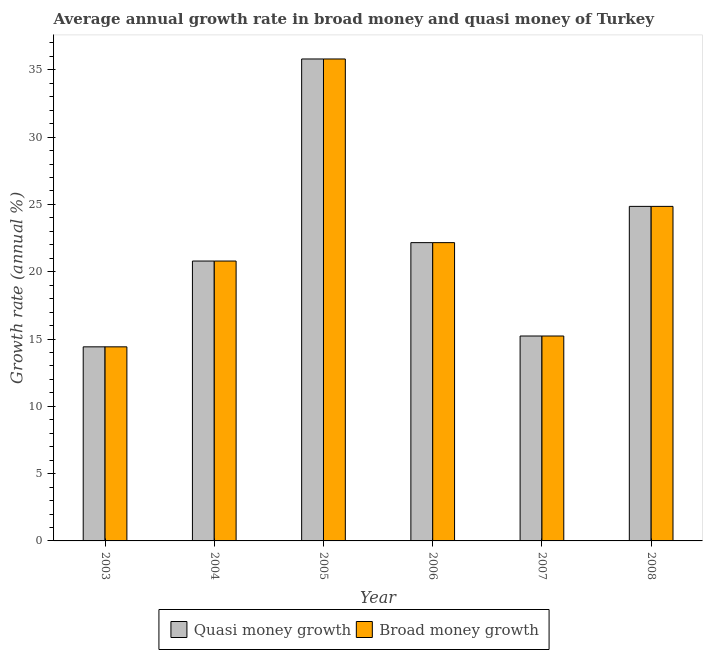How many different coloured bars are there?
Provide a short and direct response. 2. How many groups of bars are there?
Provide a succinct answer. 6. Are the number of bars per tick equal to the number of legend labels?
Your answer should be compact. Yes. How many bars are there on the 5th tick from the right?
Provide a short and direct response. 2. In how many cases, is the number of bars for a given year not equal to the number of legend labels?
Your response must be concise. 0. What is the annual growth rate in quasi money in 2005?
Offer a terse response. 35.81. Across all years, what is the maximum annual growth rate in broad money?
Make the answer very short. 35.81. Across all years, what is the minimum annual growth rate in broad money?
Provide a short and direct response. 14.42. In which year was the annual growth rate in quasi money maximum?
Give a very brief answer. 2005. What is the total annual growth rate in broad money in the graph?
Provide a succinct answer. 133.27. What is the difference between the annual growth rate in quasi money in 2005 and that in 2007?
Provide a short and direct response. 20.58. What is the difference between the annual growth rate in broad money in 2005 and the annual growth rate in quasi money in 2004?
Offer a terse response. 15.01. What is the average annual growth rate in quasi money per year?
Offer a very short reply. 22.21. In the year 2008, what is the difference between the annual growth rate in broad money and annual growth rate in quasi money?
Keep it short and to the point. 0. In how many years, is the annual growth rate in quasi money greater than 33 %?
Your answer should be compact. 1. What is the ratio of the annual growth rate in quasi money in 2003 to that in 2006?
Offer a terse response. 0.65. Is the annual growth rate in broad money in 2003 less than that in 2004?
Offer a very short reply. Yes. What is the difference between the highest and the second highest annual growth rate in quasi money?
Provide a succinct answer. 10.95. What is the difference between the highest and the lowest annual growth rate in broad money?
Ensure brevity in your answer.  21.39. In how many years, is the annual growth rate in quasi money greater than the average annual growth rate in quasi money taken over all years?
Provide a short and direct response. 2. Is the sum of the annual growth rate in quasi money in 2007 and 2008 greater than the maximum annual growth rate in broad money across all years?
Give a very brief answer. Yes. What does the 2nd bar from the left in 2003 represents?
Your answer should be compact. Broad money growth. What does the 2nd bar from the right in 2008 represents?
Provide a succinct answer. Quasi money growth. How many bars are there?
Keep it short and to the point. 12. What is the difference between two consecutive major ticks on the Y-axis?
Ensure brevity in your answer.  5. Are the values on the major ticks of Y-axis written in scientific E-notation?
Your response must be concise. No. Does the graph contain any zero values?
Provide a short and direct response. No. How are the legend labels stacked?
Offer a very short reply. Horizontal. What is the title of the graph?
Your answer should be very brief. Average annual growth rate in broad money and quasi money of Turkey. What is the label or title of the X-axis?
Your answer should be compact. Year. What is the label or title of the Y-axis?
Your response must be concise. Growth rate (annual %). What is the Growth rate (annual %) in Quasi money growth in 2003?
Your answer should be very brief. 14.42. What is the Growth rate (annual %) in Broad money growth in 2003?
Your response must be concise. 14.42. What is the Growth rate (annual %) of Quasi money growth in 2004?
Provide a short and direct response. 20.8. What is the Growth rate (annual %) of Broad money growth in 2004?
Make the answer very short. 20.8. What is the Growth rate (annual %) in Quasi money growth in 2005?
Your answer should be compact. 35.81. What is the Growth rate (annual %) of Broad money growth in 2005?
Keep it short and to the point. 35.81. What is the Growth rate (annual %) of Quasi money growth in 2006?
Your answer should be compact. 22.16. What is the Growth rate (annual %) in Broad money growth in 2006?
Offer a very short reply. 22.16. What is the Growth rate (annual %) in Quasi money growth in 2007?
Your answer should be very brief. 15.23. What is the Growth rate (annual %) in Broad money growth in 2007?
Give a very brief answer. 15.23. What is the Growth rate (annual %) of Quasi money growth in 2008?
Keep it short and to the point. 24.86. What is the Growth rate (annual %) of Broad money growth in 2008?
Your answer should be compact. 24.86. Across all years, what is the maximum Growth rate (annual %) in Quasi money growth?
Offer a terse response. 35.81. Across all years, what is the maximum Growth rate (annual %) in Broad money growth?
Ensure brevity in your answer.  35.81. Across all years, what is the minimum Growth rate (annual %) of Quasi money growth?
Your response must be concise. 14.42. Across all years, what is the minimum Growth rate (annual %) of Broad money growth?
Provide a short and direct response. 14.42. What is the total Growth rate (annual %) of Quasi money growth in the graph?
Offer a very short reply. 133.27. What is the total Growth rate (annual %) in Broad money growth in the graph?
Offer a very short reply. 133.27. What is the difference between the Growth rate (annual %) in Quasi money growth in 2003 and that in 2004?
Your answer should be very brief. -6.38. What is the difference between the Growth rate (annual %) of Broad money growth in 2003 and that in 2004?
Offer a terse response. -6.38. What is the difference between the Growth rate (annual %) of Quasi money growth in 2003 and that in 2005?
Provide a short and direct response. -21.39. What is the difference between the Growth rate (annual %) in Broad money growth in 2003 and that in 2005?
Keep it short and to the point. -21.39. What is the difference between the Growth rate (annual %) of Quasi money growth in 2003 and that in 2006?
Your response must be concise. -7.74. What is the difference between the Growth rate (annual %) of Broad money growth in 2003 and that in 2006?
Make the answer very short. -7.74. What is the difference between the Growth rate (annual %) in Quasi money growth in 2003 and that in 2007?
Make the answer very short. -0.81. What is the difference between the Growth rate (annual %) in Broad money growth in 2003 and that in 2007?
Offer a terse response. -0.81. What is the difference between the Growth rate (annual %) of Quasi money growth in 2003 and that in 2008?
Provide a succinct answer. -10.44. What is the difference between the Growth rate (annual %) of Broad money growth in 2003 and that in 2008?
Give a very brief answer. -10.44. What is the difference between the Growth rate (annual %) in Quasi money growth in 2004 and that in 2005?
Your answer should be compact. -15.01. What is the difference between the Growth rate (annual %) of Broad money growth in 2004 and that in 2005?
Keep it short and to the point. -15.01. What is the difference between the Growth rate (annual %) of Quasi money growth in 2004 and that in 2006?
Ensure brevity in your answer.  -1.37. What is the difference between the Growth rate (annual %) of Broad money growth in 2004 and that in 2006?
Offer a very short reply. -1.37. What is the difference between the Growth rate (annual %) of Quasi money growth in 2004 and that in 2007?
Offer a terse response. 5.57. What is the difference between the Growth rate (annual %) in Broad money growth in 2004 and that in 2007?
Your response must be concise. 5.57. What is the difference between the Growth rate (annual %) of Quasi money growth in 2004 and that in 2008?
Provide a short and direct response. -4.06. What is the difference between the Growth rate (annual %) of Broad money growth in 2004 and that in 2008?
Your response must be concise. -4.06. What is the difference between the Growth rate (annual %) in Quasi money growth in 2005 and that in 2006?
Offer a terse response. 13.65. What is the difference between the Growth rate (annual %) of Broad money growth in 2005 and that in 2006?
Make the answer very short. 13.65. What is the difference between the Growth rate (annual %) of Quasi money growth in 2005 and that in 2007?
Provide a succinct answer. 20.58. What is the difference between the Growth rate (annual %) of Broad money growth in 2005 and that in 2007?
Provide a succinct answer. 20.58. What is the difference between the Growth rate (annual %) in Quasi money growth in 2005 and that in 2008?
Ensure brevity in your answer.  10.95. What is the difference between the Growth rate (annual %) in Broad money growth in 2005 and that in 2008?
Provide a short and direct response. 10.95. What is the difference between the Growth rate (annual %) of Quasi money growth in 2006 and that in 2007?
Your answer should be very brief. 6.94. What is the difference between the Growth rate (annual %) in Broad money growth in 2006 and that in 2007?
Provide a short and direct response. 6.94. What is the difference between the Growth rate (annual %) of Quasi money growth in 2006 and that in 2008?
Give a very brief answer. -2.69. What is the difference between the Growth rate (annual %) of Broad money growth in 2006 and that in 2008?
Give a very brief answer. -2.69. What is the difference between the Growth rate (annual %) of Quasi money growth in 2007 and that in 2008?
Ensure brevity in your answer.  -9.63. What is the difference between the Growth rate (annual %) of Broad money growth in 2007 and that in 2008?
Your answer should be compact. -9.63. What is the difference between the Growth rate (annual %) of Quasi money growth in 2003 and the Growth rate (annual %) of Broad money growth in 2004?
Offer a very short reply. -6.38. What is the difference between the Growth rate (annual %) of Quasi money growth in 2003 and the Growth rate (annual %) of Broad money growth in 2005?
Your answer should be compact. -21.39. What is the difference between the Growth rate (annual %) of Quasi money growth in 2003 and the Growth rate (annual %) of Broad money growth in 2006?
Offer a terse response. -7.74. What is the difference between the Growth rate (annual %) in Quasi money growth in 2003 and the Growth rate (annual %) in Broad money growth in 2007?
Your response must be concise. -0.81. What is the difference between the Growth rate (annual %) in Quasi money growth in 2003 and the Growth rate (annual %) in Broad money growth in 2008?
Offer a very short reply. -10.44. What is the difference between the Growth rate (annual %) of Quasi money growth in 2004 and the Growth rate (annual %) of Broad money growth in 2005?
Offer a very short reply. -15.01. What is the difference between the Growth rate (annual %) in Quasi money growth in 2004 and the Growth rate (annual %) in Broad money growth in 2006?
Your answer should be very brief. -1.37. What is the difference between the Growth rate (annual %) of Quasi money growth in 2004 and the Growth rate (annual %) of Broad money growth in 2007?
Offer a terse response. 5.57. What is the difference between the Growth rate (annual %) in Quasi money growth in 2004 and the Growth rate (annual %) in Broad money growth in 2008?
Offer a terse response. -4.06. What is the difference between the Growth rate (annual %) of Quasi money growth in 2005 and the Growth rate (annual %) of Broad money growth in 2006?
Make the answer very short. 13.65. What is the difference between the Growth rate (annual %) in Quasi money growth in 2005 and the Growth rate (annual %) in Broad money growth in 2007?
Ensure brevity in your answer.  20.58. What is the difference between the Growth rate (annual %) of Quasi money growth in 2005 and the Growth rate (annual %) of Broad money growth in 2008?
Make the answer very short. 10.95. What is the difference between the Growth rate (annual %) of Quasi money growth in 2006 and the Growth rate (annual %) of Broad money growth in 2007?
Offer a terse response. 6.94. What is the difference between the Growth rate (annual %) in Quasi money growth in 2006 and the Growth rate (annual %) in Broad money growth in 2008?
Provide a succinct answer. -2.69. What is the difference between the Growth rate (annual %) in Quasi money growth in 2007 and the Growth rate (annual %) in Broad money growth in 2008?
Give a very brief answer. -9.63. What is the average Growth rate (annual %) in Quasi money growth per year?
Offer a very short reply. 22.21. What is the average Growth rate (annual %) of Broad money growth per year?
Keep it short and to the point. 22.21. In the year 2005, what is the difference between the Growth rate (annual %) in Quasi money growth and Growth rate (annual %) in Broad money growth?
Offer a terse response. 0. In the year 2007, what is the difference between the Growth rate (annual %) of Quasi money growth and Growth rate (annual %) of Broad money growth?
Offer a terse response. 0. In the year 2008, what is the difference between the Growth rate (annual %) in Quasi money growth and Growth rate (annual %) in Broad money growth?
Make the answer very short. 0. What is the ratio of the Growth rate (annual %) of Quasi money growth in 2003 to that in 2004?
Give a very brief answer. 0.69. What is the ratio of the Growth rate (annual %) of Broad money growth in 2003 to that in 2004?
Keep it short and to the point. 0.69. What is the ratio of the Growth rate (annual %) of Quasi money growth in 2003 to that in 2005?
Offer a terse response. 0.4. What is the ratio of the Growth rate (annual %) of Broad money growth in 2003 to that in 2005?
Make the answer very short. 0.4. What is the ratio of the Growth rate (annual %) of Quasi money growth in 2003 to that in 2006?
Ensure brevity in your answer.  0.65. What is the ratio of the Growth rate (annual %) in Broad money growth in 2003 to that in 2006?
Offer a very short reply. 0.65. What is the ratio of the Growth rate (annual %) in Quasi money growth in 2003 to that in 2007?
Provide a short and direct response. 0.95. What is the ratio of the Growth rate (annual %) in Broad money growth in 2003 to that in 2007?
Your answer should be compact. 0.95. What is the ratio of the Growth rate (annual %) in Quasi money growth in 2003 to that in 2008?
Provide a short and direct response. 0.58. What is the ratio of the Growth rate (annual %) in Broad money growth in 2003 to that in 2008?
Ensure brevity in your answer.  0.58. What is the ratio of the Growth rate (annual %) in Quasi money growth in 2004 to that in 2005?
Your answer should be very brief. 0.58. What is the ratio of the Growth rate (annual %) in Broad money growth in 2004 to that in 2005?
Your answer should be very brief. 0.58. What is the ratio of the Growth rate (annual %) of Quasi money growth in 2004 to that in 2006?
Your response must be concise. 0.94. What is the ratio of the Growth rate (annual %) of Broad money growth in 2004 to that in 2006?
Offer a terse response. 0.94. What is the ratio of the Growth rate (annual %) in Quasi money growth in 2004 to that in 2007?
Provide a succinct answer. 1.37. What is the ratio of the Growth rate (annual %) of Broad money growth in 2004 to that in 2007?
Offer a very short reply. 1.37. What is the ratio of the Growth rate (annual %) in Quasi money growth in 2004 to that in 2008?
Offer a very short reply. 0.84. What is the ratio of the Growth rate (annual %) in Broad money growth in 2004 to that in 2008?
Provide a short and direct response. 0.84. What is the ratio of the Growth rate (annual %) of Quasi money growth in 2005 to that in 2006?
Keep it short and to the point. 1.62. What is the ratio of the Growth rate (annual %) of Broad money growth in 2005 to that in 2006?
Your answer should be very brief. 1.62. What is the ratio of the Growth rate (annual %) in Quasi money growth in 2005 to that in 2007?
Provide a succinct answer. 2.35. What is the ratio of the Growth rate (annual %) of Broad money growth in 2005 to that in 2007?
Ensure brevity in your answer.  2.35. What is the ratio of the Growth rate (annual %) in Quasi money growth in 2005 to that in 2008?
Your response must be concise. 1.44. What is the ratio of the Growth rate (annual %) of Broad money growth in 2005 to that in 2008?
Make the answer very short. 1.44. What is the ratio of the Growth rate (annual %) in Quasi money growth in 2006 to that in 2007?
Your response must be concise. 1.46. What is the ratio of the Growth rate (annual %) in Broad money growth in 2006 to that in 2007?
Your response must be concise. 1.46. What is the ratio of the Growth rate (annual %) of Quasi money growth in 2006 to that in 2008?
Keep it short and to the point. 0.89. What is the ratio of the Growth rate (annual %) of Broad money growth in 2006 to that in 2008?
Your answer should be compact. 0.89. What is the ratio of the Growth rate (annual %) in Quasi money growth in 2007 to that in 2008?
Your answer should be compact. 0.61. What is the ratio of the Growth rate (annual %) of Broad money growth in 2007 to that in 2008?
Offer a very short reply. 0.61. What is the difference between the highest and the second highest Growth rate (annual %) of Quasi money growth?
Give a very brief answer. 10.95. What is the difference between the highest and the second highest Growth rate (annual %) of Broad money growth?
Give a very brief answer. 10.95. What is the difference between the highest and the lowest Growth rate (annual %) of Quasi money growth?
Your answer should be very brief. 21.39. What is the difference between the highest and the lowest Growth rate (annual %) of Broad money growth?
Offer a terse response. 21.39. 